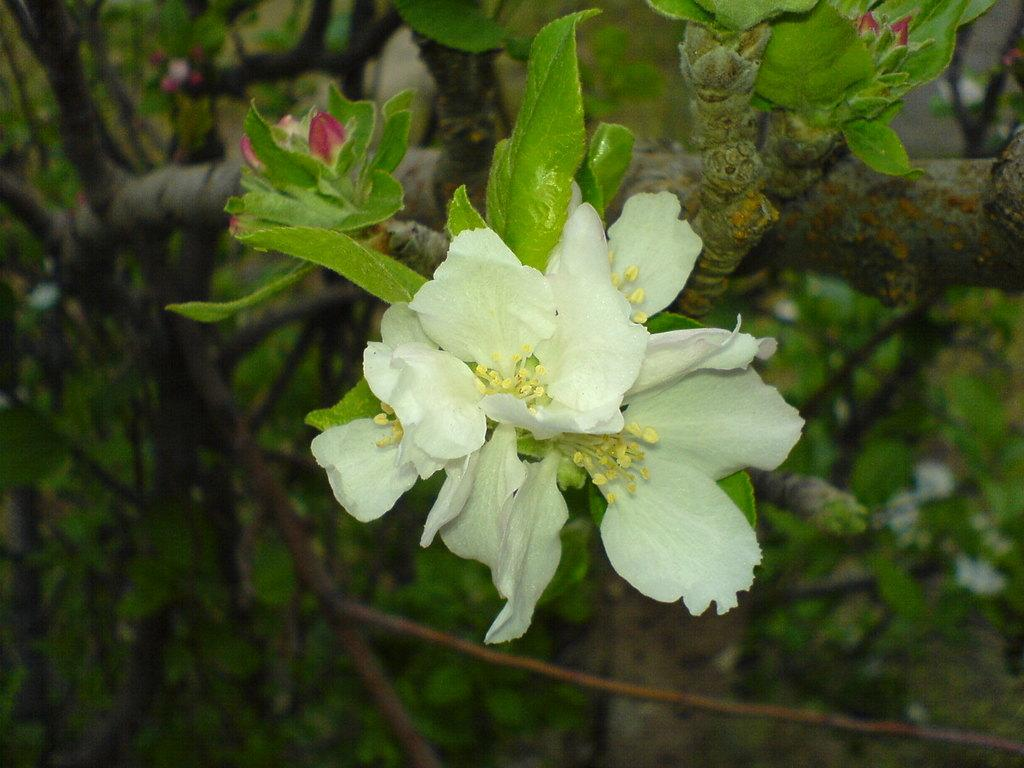What color is the flower in the image? The flower is white in color. Can you describe any other part of the flower in the image? There is a flower bud in the image. What else can be seen in the image besides the flower? Leaves and branches are visible in the image. What type of cloth is draped over the flower in the image? There is no cloth present in the image; it only features the flower, flower bud, leaves, and branches. 